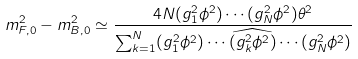<formula> <loc_0><loc_0><loc_500><loc_500>m _ { F , 0 } ^ { 2 } - m _ { B , 0 } ^ { 2 } \simeq \frac { 4 N ( g _ { 1 } ^ { 2 } \phi ^ { 2 } ) \cdots ( g _ { N } ^ { 2 } \phi ^ { 2 } ) \theta ^ { 2 } } { \sum _ { k = 1 } ^ { N } ( g _ { 1 } ^ { 2 } \phi ^ { 2 } ) \cdots \widehat { ( g _ { k } ^ { 2 } \phi ^ { 2 } ) } \cdots ( g _ { N } ^ { 2 } \phi ^ { 2 } ) }</formula> 